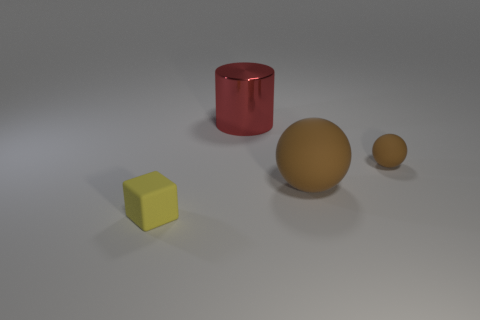Are there any other things that are the same size as the yellow matte cube?
Keep it short and to the point. Yes. Are there fewer tiny brown balls that are in front of the tiny yellow object than cyan matte cylinders?
Ensure brevity in your answer.  No. Do the yellow rubber object and the red thing have the same shape?
Provide a short and direct response. No. There is another object that is the same shape as the tiny brown matte object; what color is it?
Provide a succinct answer. Brown. What number of small spheres have the same color as the large rubber thing?
Keep it short and to the point. 1. What number of things are either small rubber objects that are behind the block or tiny red rubber spheres?
Ensure brevity in your answer.  1. There is a rubber object left of the large red cylinder; how big is it?
Offer a very short reply. Small. Are there fewer big gray spheres than large brown spheres?
Ensure brevity in your answer.  Yes. Is the material of the tiny object that is to the left of the red metallic object the same as the large thing in front of the red metallic cylinder?
Make the answer very short. Yes. The object that is to the left of the large red shiny cylinder that is left of the small matte thing that is to the right of the small yellow object is what shape?
Offer a terse response. Cube. 